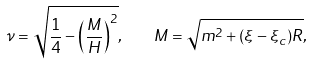<formula> <loc_0><loc_0><loc_500><loc_500>\nu = \sqrt { \frac { 1 } { 4 } - \left ( \frac { M } { H } \right ) ^ { 2 } } , \quad M = \sqrt { m ^ { 2 } + ( \xi - \xi _ { c } ) R } ,</formula> 